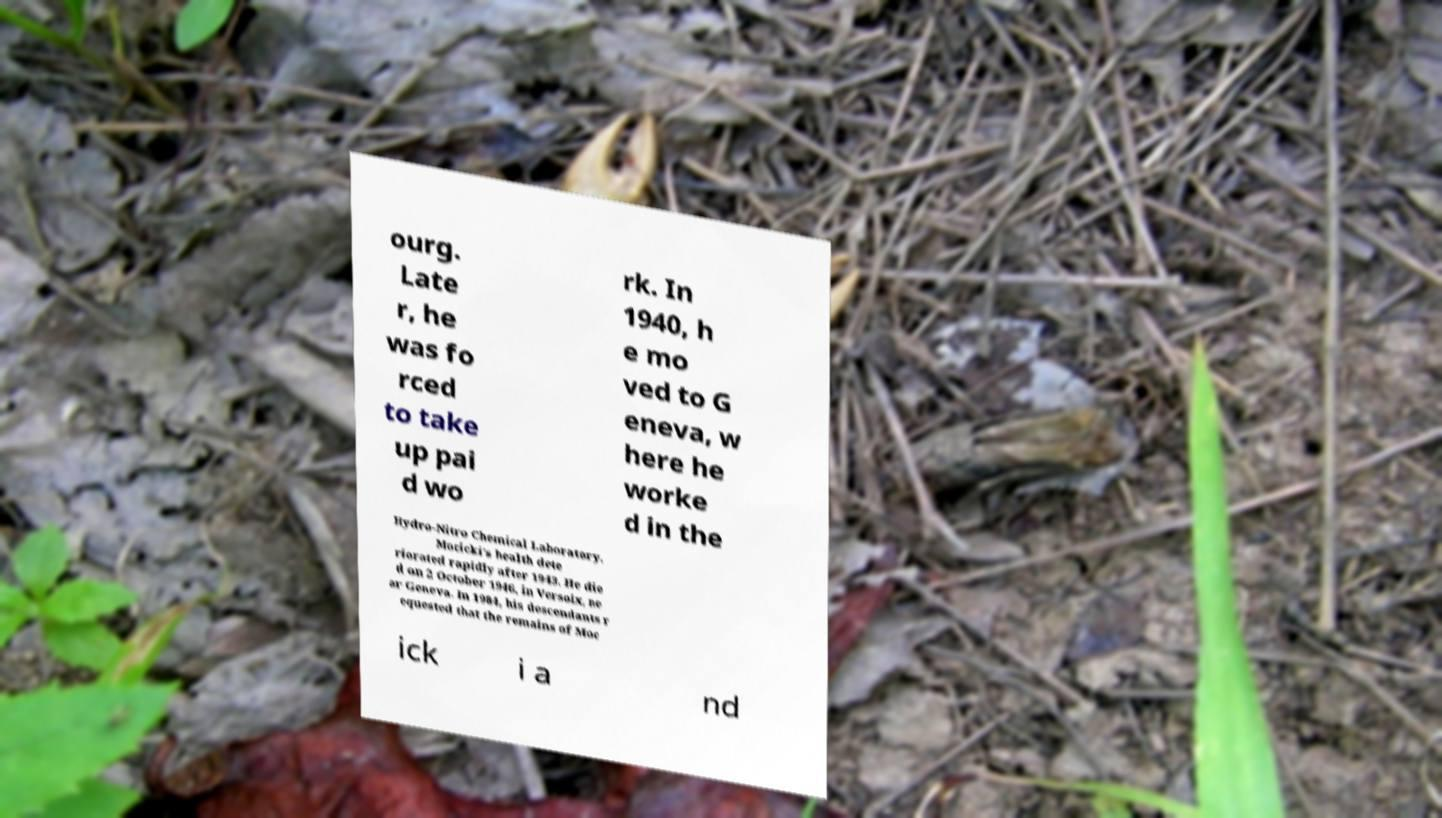I need the written content from this picture converted into text. Can you do that? ourg. Late r, he was fo rced to take up pai d wo rk. In 1940, h e mo ved to G eneva, w here he worke d in the Hydro-Nitro Chemical Laboratory. Mocicki's health dete riorated rapidly after 1943. He die d on 2 October 1946, in Versoix, ne ar Geneva. In 1984, his descendants r equested that the remains of Moc ick i a nd 